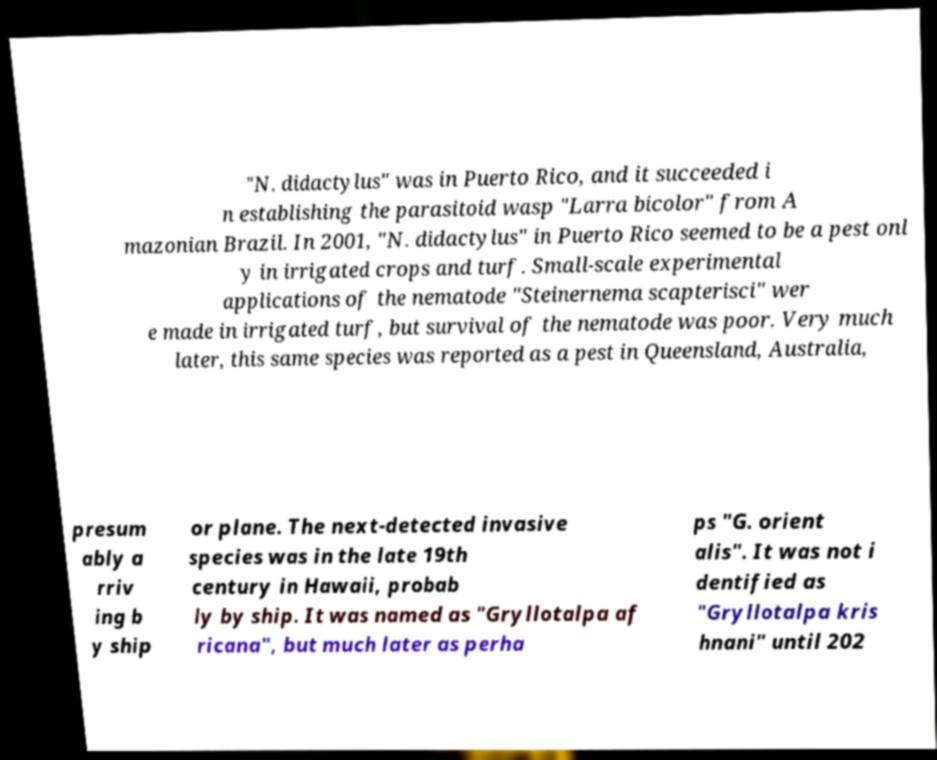Could you extract and type out the text from this image? "N. didactylus" was in Puerto Rico, and it succeeded i n establishing the parasitoid wasp "Larra bicolor" from A mazonian Brazil. In 2001, "N. didactylus" in Puerto Rico seemed to be a pest onl y in irrigated crops and turf. Small-scale experimental applications of the nematode "Steinernema scapterisci" wer e made in irrigated turf, but survival of the nematode was poor. Very much later, this same species was reported as a pest in Queensland, Australia, presum ably a rriv ing b y ship or plane. The next-detected invasive species was in the late 19th century in Hawaii, probab ly by ship. It was named as "Gryllotalpa af ricana", but much later as perha ps "G. orient alis". It was not i dentified as "Gryllotalpa kris hnani" until 202 